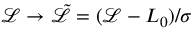<formula> <loc_0><loc_0><loc_500><loc_500>\mathcal { L } \rightarrow \tilde { \mathcal { L } } = ( \mathcal { L } - L _ { 0 } ) / \sigma</formula> 